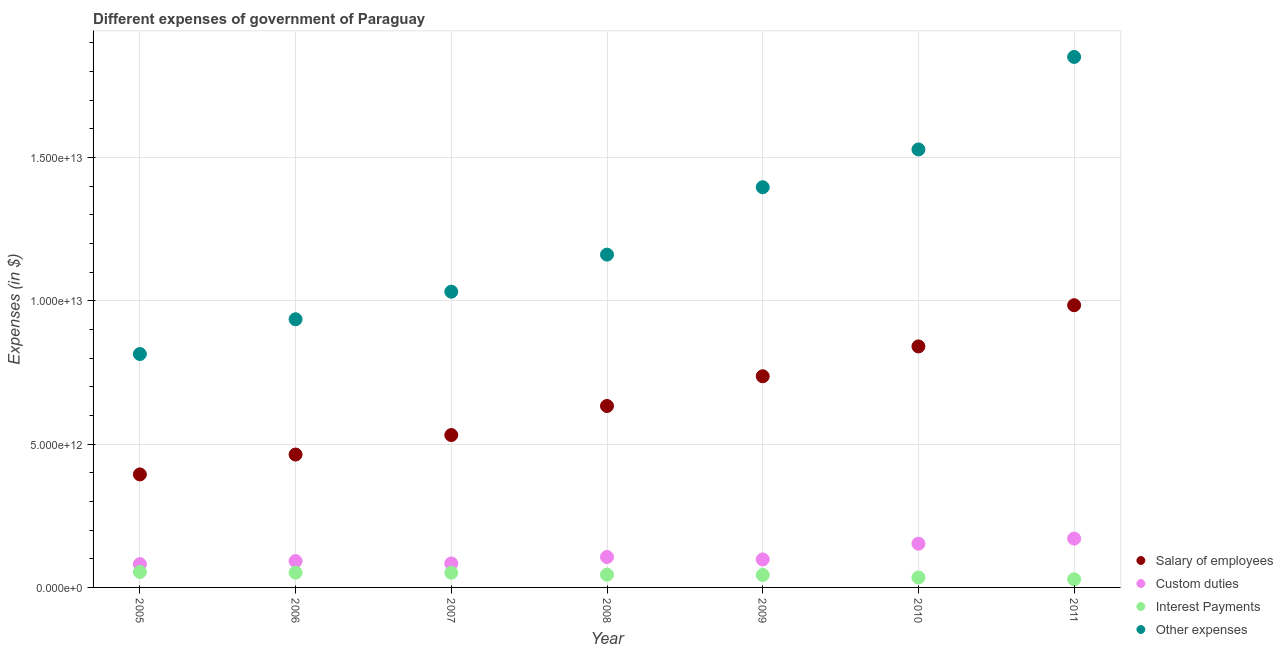How many different coloured dotlines are there?
Provide a succinct answer. 4. Is the number of dotlines equal to the number of legend labels?
Make the answer very short. Yes. What is the amount spent on other expenses in 2009?
Your answer should be very brief. 1.40e+13. Across all years, what is the maximum amount spent on salary of employees?
Your answer should be very brief. 9.85e+12. Across all years, what is the minimum amount spent on salary of employees?
Offer a terse response. 3.94e+12. In which year was the amount spent on interest payments minimum?
Your response must be concise. 2011. What is the total amount spent on salary of employees in the graph?
Provide a succinct answer. 4.59e+13. What is the difference between the amount spent on interest payments in 2007 and that in 2009?
Make the answer very short. 7.83e+1. What is the difference between the amount spent on salary of employees in 2011 and the amount spent on other expenses in 2008?
Your answer should be compact. -1.77e+12. What is the average amount spent on custom duties per year?
Keep it short and to the point. 1.12e+12. In the year 2008, what is the difference between the amount spent on salary of employees and amount spent on other expenses?
Offer a terse response. -5.28e+12. In how many years, is the amount spent on interest payments greater than 1000000000000 $?
Keep it short and to the point. 0. What is the ratio of the amount spent on interest payments in 2008 to that in 2011?
Make the answer very short. 1.57. Is the difference between the amount spent on other expenses in 2005 and 2006 greater than the difference between the amount spent on interest payments in 2005 and 2006?
Provide a short and direct response. No. What is the difference between the highest and the second highest amount spent on other expenses?
Offer a terse response. 3.23e+12. What is the difference between the highest and the lowest amount spent on salary of employees?
Your answer should be compact. 5.90e+12. In how many years, is the amount spent on salary of employees greater than the average amount spent on salary of employees taken over all years?
Your answer should be very brief. 3. Is the sum of the amount spent on salary of employees in 2010 and 2011 greater than the maximum amount spent on interest payments across all years?
Make the answer very short. Yes. How many years are there in the graph?
Offer a terse response. 7. What is the difference between two consecutive major ticks on the Y-axis?
Your response must be concise. 5.00e+12. Are the values on the major ticks of Y-axis written in scientific E-notation?
Provide a short and direct response. Yes. Does the graph contain grids?
Keep it short and to the point. Yes. How many legend labels are there?
Provide a short and direct response. 4. What is the title of the graph?
Ensure brevity in your answer.  Different expenses of government of Paraguay. Does "International Monetary Fund" appear as one of the legend labels in the graph?
Give a very brief answer. No. What is the label or title of the X-axis?
Your answer should be very brief. Year. What is the label or title of the Y-axis?
Make the answer very short. Expenses (in $). What is the Expenses (in $) in Salary of employees in 2005?
Your answer should be very brief. 3.94e+12. What is the Expenses (in $) in Custom duties in 2005?
Provide a succinct answer. 8.13e+11. What is the Expenses (in $) of Interest Payments in 2005?
Offer a very short reply. 5.40e+11. What is the Expenses (in $) in Other expenses in 2005?
Give a very brief answer. 8.15e+12. What is the Expenses (in $) of Salary of employees in 2006?
Your answer should be very brief. 4.64e+12. What is the Expenses (in $) of Custom duties in 2006?
Offer a terse response. 9.18e+11. What is the Expenses (in $) in Interest Payments in 2006?
Provide a succinct answer. 5.17e+11. What is the Expenses (in $) in Other expenses in 2006?
Ensure brevity in your answer.  9.36e+12. What is the Expenses (in $) of Salary of employees in 2007?
Provide a succinct answer. 5.32e+12. What is the Expenses (in $) in Custom duties in 2007?
Keep it short and to the point. 8.38e+11. What is the Expenses (in $) in Interest Payments in 2007?
Provide a short and direct response. 5.13e+11. What is the Expenses (in $) of Other expenses in 2007?
Provide a succinct answer. 1.03e+13. What is the Expenses (in $) in Salary of employees in 2008?
Keep it short and to the point. 6.33e+12. What is the Expenses (in $) of Custom duties in 2008?
Offer a very short reply. 1.06e+12. What is the Expenses (in $) of Interest Payments in 2008?
Ensure brevity in your answer.  4.45e+11. What is the Expenses (in $) in Other expenses in 2008?
Keep it short and to the point. 1.16e+13. What is the Expenses (in $) of Salary of employees in 2009?
Your answer should be very brief. 7.37e+12. What is the Expenses (in $) of Custom duties in 2009?
Your answer should be compact. 9.77e+11. What is the Expenses (in $) of Interest Payments in 2009?
Your response must be concise. 4.35e+11. What is the Expenses (in $) in Other expenses in 2009?
Offer a terse response. 1.40e+13. What is the Expenses (in $) in Salary of employees in 2010?
Your answer should be compact. 8.41e+12. What is the Expenses (in $) of Custom duties in 2010?
Offer a terse response. 1.53e+12. What is the Expenses (in $) in Interest Payments in 2010?
Your response must be concise. 3.46e+11. What is the Expenses (in $) in Other expenses in 2010?
Offer a very short reply. 1.53e+13. What is the Expenses (in $) of Salary of employees in 2011?
Ensure brevity in your answer.  9.85e+12. What is the Expenses (in $) of Custom duties in 2011?
Ensure brevity in your answer.  1.70e+12. What is the Expenses (in $) in Interest Payments in 2011?
Your answer should be very brief. 2.84e+11. What is the Expenses (in $) in Other expenses in 2011?
Ensure brevity in your answer.  1.85e+13. Across all years, what is the maximum Expenses (in $) of Salary of employees?
Offer a terse response. 9.85e+12. Across all years, what is the maximum Expenses (in $) of Custom duties?
Provide a succinct answer. 1.70e+12. Across all years, what is the maximum Expenses (in $) in Interest Payments?
Offer a terse response. 5.40e+11. Across all years, what is the maximum Expenses (in $) of Other expenses?
Your response must be concise. 1.85e+13. Across all years, what is the minimum Expenses (in $) of Salary of employees?
Offer a very short reply. 3.94e+12. Across all years, what is the minimum Expenses (in $) in Custom duties?
Keep it short and to the point. 8.13e+11. Across all years, what is the minimum Expenses (in $) in Interest Payments?
Provide a short and direct response. 2.84e+11. Across all years, what is the minimum Expenses (in $) of Other expenses?
Make the answer very short. 8.15e+12. What is the total Expenses (in $) in Salary of employees in the graph?
Your response must be concise. 4.59e+13. What is the total Expenses (in $) in Custom duties in the graph?
Provide a short and direct response. 7.84e+12. What is the total Expenses (in $) in Interest Payments in the graph?
Provide a short and direct response. 3.08e+12. What is the total Expenses (in $) in Other expenses in the graph?
Your response must be concise. 8.72e+13. What is the difference between the Expenses (in $) of Salary of employees in 2005 and that in 2006?
Give a very brief answer. -6.94e+11. What is the difference between the Expenses (in $) in Custom duties in 2005 and that in 2006?
Your answer should be compact. -1.06e+11. What is the difference between the Expenses (in $) of Interest Payments in 2005 and that in 2006?
Give a very brief answer. 2.30e+1. What is the difference between the Expenses (in $) in Other expenses in 2005 and that in 2006?
Ensure brevity in your answer.  -1.21e+12. What is the difference between the Expenses (in $) in Salary of employees in 2005 and that in 2007?
Offer a terse response. -1.37e+12. What is the difference between the Expenses (in $) in Custom duties in 2005 and that in 2007?
Offer a very short reply. -2.49e+1. What is the difference between the Expenses (in $) in Interest Payments in 2005 and that in 2007?
Offer a very short reply. 2.69e+1. What is the difference between the Expenses (in $) of Other expenses in 2005 and that in 2007?
Your answer should be very brief. -2.17e+12. What is the difference between the Expenses (in $) in Salary of employees in 2005 and that in 2008?
Offer a terse response. -2.39e+12. What is the difference between the Expenses (in $) of Custom duties in 2005 and that in 2008?
Your response must be concise. -2.49e+11. What is the difference between the Expenses (in $) in Interest Payments in 2005 and that in 2008?
Provide a short and direct response. 9.46e+1. What is the difference between the Expenses (in $) in Other expenses in 2005 and that in 2008?
Your answer should be compact. -3.47e+12. What is the difference between the Expenses (in $) of Salary of employees in 2005 and that in 2009?
Make the answer very short. -3.42e+12. What is the difference between the Expenses (in $) in Custom duties in 2005 and that in 2009?
Ensure brevity in your answer.  -1.65e+11. What is the difference between the Expenses (in $) in Interest Payments in 2005 and that in 2009?
Your response must be concise. 1.05e+11. What is the difference between the Expenses (in $) of Other expenses in 2005 and that in 2009?
Keep it short and to the point. -5.82e+12. What is the difference between the Expenses (in $) of Salary of employees in 2005 and that in 2010?
Your answer should be compact. -4.47e+12. What is the difference between the Expenses (in $) of Custom duties in 2005 and that in 2010?
Give a very brief answer. -7.13e+11. What is the difference between the Expenses (in $) of Interest Payments in 2005 and that in 2010?
Offer a terse response. 1.93e+11. What is the difference between the Expenses (in $) in Other expenses in 2005 and that in 2010?
Provide a succinct answer. -7.14e+12. What is the difference between the Expenses (in $) of Salary of employees in 2005 and that in 2011?
Make the answer very short. -5.90e+12. What is the difference between the Expenses (in $) of Custom duties in 2005 and that in 2011?
Your response must be concise. -8.91e+11. What is the difference between the Expenses (in $) of Interest Payments in 2005 and that in 2011?
Your response must be concise. 2.56e+11. What is the difference between the Expenses (in $) of Other expenses in 2005 and that in 2011?
Ensure brevity in your answer.  -1.04e+13. What is the difference between the Expenses (in $) in Salary of employees in 2006 and that in 2007?
Offer a very short reply. -6.80e+11. What is the difference between the Expenses (in $) in Custom duties in 2006 and that in 2007?
Offer a terse response. 8.09e+1. What is the difference between the Expenses (in $) in Interest Payments in 2006 and that in 2007?
Offer a terse response. 3.87e+09. What is the difference between the Expenses (in $) of Other expenses in 2006 and that in 2007?
Provide a short and direct response. -9.61e+11. What is the difference between the Expenses (in $) of Salary of employees in 2006 and that in 2008?
Make the answer very short. -1.69e+12. What is the difference between the Expenses (in $) in Custom duties in 2006 and that in 2008?
Offer a very short reply. -1.43e+11. What is the difference between the Expenses (in $) of Interest Payments in 2006 and that in 2008?
Your answer should be compact. 7.16e+1. What is the difference between the Expenses (in $) in Other expenses in 2006 and that in 2008?
Make the answer very short. -2.26e+12. What is the difference between the Expenses (in $) in Salary of employees in 2006 and that in 2009?
Your answer should be very brief. -2.73e+12. What is the difference between the Expenses (in $) of Custom duties in 2006 and that in 2009?
Give a very brief answer. -5.89e+1. What is the difference between the Expenses (in $) in Interest Payments in 2006 and that in 2009?
Provide a succinct answer. 8.22e+1. What is the difference between the Expenses (in $) in Other expenses in 2006 and that in 2009?
Offer a very short reply. -4.61e+12. What is the difference between the Expenses (in $) of Salary of employees in 2006 and that in 2010?
Keep it short and to the point. -3.77e+12. What is the difference between the Expenses (in $) of Custom duties in 2006 and that in 2010?
Offer a terse response. -6.07e+11. What is the difference between the Expenses (in $) of Interest Payments in 2006 and that in 2010?
Your answer should be very brief. 1.70e+11. What is the difference between the Expenses (in $) in Other expenses in 2006 and that in 2010?
Give a very brief answer. -5.93e+12. What is the difference between the Expenses (in $) in Salary of employees in 2006 and that in 2011?
Keep it short and to the point. -5.21e+12. What is the difference between the Expenses (in $) of Custom duties in 2006 and that in 2011?
Provide a short and direct response. -7.85e+11. What is the difference between the Expenses (in $) of Interest Payments in 2006 and that in 2011?
Keep it short and to the point. 2.33e+11. What is the difference between the Expenses (in $) of Other expenses in 2006 and that in 2011?
Provide a short and direct response. -9.15e+12. What is the difference between the Expenses (in $) in Salary of employees in 2007 and that in 2008?
Give a very brief answer. -1.01e+12. What is the difference between the Expenses (in $) of Custom duties in 2007 and that in 2008?
Give a very brief answer. -2.24e+11. What is the difference between the Expenses (in $) of Interest Payments in 2007 and that in 2008?
Make the answer very short. 6.77e+1. What is the difference between the Expenses (in $) in Other expenses in 2007 and that in 2008?
Keep it short and to the point. -1.29e+12. What is the difference between the Expenses (in $) of Salary of employees in 2007 and that in 2009?
Ensure brevity in your answer.  -2.05e+12. What is the difference between the Expenses (in $) in Custom duties in 2007 and that in 2009?
Offer a very short reply. -1.40e+11. What is the difference between the Expenses (in $) of Interest Payments in 2007 and that in 2009?
Keep it short and to the point. 7.83e+1. What is the difference between the Expenses (in $) of Other expenses in 2007 and that in 2009?
Your answer should be very brief. -3.65e+12. What is the difference between the Expenses (in $) of Salary of employees in 2007 and that in 2010?
Provide a succinct answer. -3.09e+12. What is the difference between the Expenses (in $) in Custom duties in 2007 and that in 2010?
Your response must be concise. -6.88e+11. What is the difference between the Expenses (in $) of Interest Payments in 2007 and that in 2010?
Provide a succinct answer. 1.66e+11. What is the difference between the Expenses (in $) in Other expenses in 2007 and that in 2010?
Make the answer very short. -4.96e+12. What is the difference between the Expenses (in $) of Salary of employees in 2007 and that in 2011?
Ensure brevity in your answer.  -4.53e+12. What is the difference between the Expenses (in $) in Custom duties in 2007 and that in 2011?
Give a very brief answer. -8.66e+11. What is the difference between the Expenses (in $) in Interest Payments in 2007 and that in 2011?
Provide a succinct answer. 2.29e+11. What is the difference between the Expenses (in $) of Other expenses in 2007 and that in 2011?
Make the answer very short. -8.19e+12. What is the difference between the Expenses (in $) of Salary of employees in 2008 and that in 2009?
Ensure brevity in your answer.  -1.04e+12. What is the difference between the Expenses (in $) in Custom duties in 2008 and that in 2009?
Offer a terse response. 8.42e+1. What is the difference between the Expenses (in $) of Interest Payments in 2008 and that in 2009?
Ensure brevity in your answer.  1.06e+1. What is the difference between the Expenses (in $) in Other expenses in 2008 and that in 2009?
Offer a very short reply. -2.35e+12. What is the difference between the Expenses (in $) of Salary of employees in 2008 and that in 2010?
Offer a terse response. -2.08e+12. What is the difference between the Expenses (in $) of Custom duties in 2008 and that in 2010?
Provide a succinct answer. -4.64e+11. What is the difference between the Expenses (in $) of Interest Payments in 2008 and that in 2010?
Your response must be concise. 9.87e+1. What is the difference between the Expenses (in $) in Other expenses in 2008 and that in 2010?
Provide a succinct answer. -3.67e+12. What is the difference between the Expenses (in $) of Salary of employees in 2008 and that in 2011?
Offer a terse response. -3.52e+12. What is the difference between the Expenses (in $) in Custom duties in 2008 and that in 2011?
Ensure brevity in your answer.  -6.42e+11. What is the difference between the Expenses (in $) in Interest Payments in 2008 and that in 2011?
Provide a short and direct response. 1.61e+11. What is the difference between the Expenses (in $) in Other expenses in 2008 and that in 2011?
Make the answer very short. -6.90e+12. What is the difference between the Expenses (in $) in Salary of employees in 2009 and that in 2010?
Your answer should be very brief. -1.04e+12. What is the difference between the Expenses (in $) of Custom duties in 2009 and that in 2010?
Keep it short and to the point. -5.48e+11. What is the difference between the Expenses (in $) of Interest Payments in 2009 and that in 2010?
Provide a succinct answer. 8.81e+1. What is the difference between the Expenses (in $) in Other expenses in 2009 and that in 2010?
Offer a terse response. -1.32e+12. What is the difference between the Expenses (in $) of Salary of employees in 2009 and that in 2011?
Offer a terse response. -2.48e+12. What is the difference between the Expenses (in $) in Custom duties in 2009 and that in 2011?
Make the answer very short. -7.27e+11. What is the difference between the Expenses (in $) in Interest Payments in 2009 and that in 2011?
Keep it short and to the point. 1.50e+11. What is the difference between the Expenses (in $) of Other expenses in 2009 and that in 2011?
Ensure brevity in your answer.  -4.55e+12. What is the difference between the Expenses (in $) in Salary of employees in 2010 and that in 2011?
Offer a very short reply. -1.44e+12. What is the difference between the Expenses (in $) in Custom duties in 2010 and that in 2011?
Your answer should be compact. -1.78e+11. What is the difference between the Expenses (in $) of Interest Payments in 2010 and that in 2011?
Offer a terse response. 6.23e+1. What is the difference between the Expenses (in $) of Other expenses in 2010 and that in 2011?
Offer a very short reply. -3.23e+12. What is the difference between the Expenses (in $) of Salary of employees in 2005 and the Expenses (in $) of Custom duties in 2006?
Offer a terse response. 3.03e+12. What is the difference between the Expenses (in $) of Salary of employees in 2005 and the Expenses (in $) of Interest Payments in 2006?
Your answer should be compact. 3.43e+12. What is the difference between the Expenses (in $) in Salary of employees in 2005 and the Expenses (in $) in Other expenses in 2006?
Provide a short and direct response. -5.41e+12. What is the difference between the Expenses (in $) of Custom duties in 2005 and the Expenses (in $) of Interest Payments in 2006?
Provide a succinct answer. 2.96e+11. What is the difference between the Expenses (in $) of Custom duties in 2005 and the Expenses (in $) of Other expenses in 2006?
Ensure brevity in your answer.  -8.55e+12. What is the difference between the Expenses (in $) in Interest Payments in 2005 and the Expenses (in $) in Other expenses in 2006?
Your response must be concise. -8.82e+12. What is the difference between the Expenses (in $) in Salary of employees in 2005 and the Expenses (in $) in Custom duties in 2007?
Keep it short and to the point. 3.11e+12. What is the difference between the Expenses (in $) of Salary of employees in 2005 and the Expenses (in $) of Interest Payments in 2007?
Your answer should be compact. 3.43e+12. What is the difference between the Expenses (in $) of Salary of employees in 2005 and the Expenses (in $) of Other expenses in 2007?
Your answer should be very brief. -6.38e+12. What is the difference between the Expenses (in $) of Custom duties in 2005 and the Expenses (in $) of Interest Payments in 2007?
Offer a terse response. 3.00e+11. What is the difference between the Expenses (in $) in Custom duties in 2005 and the Expenses (in $) in Other expenses in 2007?
Offer a very short reply. -9.51e+12. What is the difference between the Expenses (in $) of Interest Payments in 2005 and the Expenses (in $) of Other expenses in 2007?
Offer a very short reply. -9.78e+12. What is the difference between the Expenses (in $) in Salary of employees in 2005 and the Expenses (in $) in Custom duties in 2008?
Give a very brief answer. 2.88e+12. What is the difference between the Expenses (in $) of Salary of employees in 2005 and the Expenses (in $) of Interest Payments in 2008?
Offer a very short reply. 3.50e+12. What is the difference between the Expenses (in $) in Salary of employees in 2005 and the Expenses (in $) in Other expenses in 2008?
Provide a succinct answer. -7.67e+12. What is the difference between the Expenses (in $) in Custom duties in 2005 and the Expenses (in $) in Interest Payments in 2008?
Provide a succinct answer. 3.68e+11. What is the difference between the Expenses (in $) in Custom duties in 2005 and the Expenses (in $) in Other expenses in 2008?
Make the answer very short. -1.08e+13. What is the difference between the Expenses (in $) in Interest Payments in 2005 and the Expenses (in $) in Other expenses in 2008?
Offer a very short reply. -1.11e+13. What is the difference between the Expenses (in $) in Salary of employees in 2005 and the Expenses (in $) in Custom duties in 2009?
Keep it short and to the point. 2.97e+12. What is the difference between the Expenses (in $) of Salary of employees in 2005 and the Expenses (in $) of Interest Payments in 2009?
Provide a succinct answer. 3.51e+12. What is the difference between the Expenses (in $) in Salary of employees in 2005 and the Expenses (in $) in Other expenses in 2009?
Give a very brief answer. -1.00e+13. What is the difference between the Expenses (in $) of Custom duties in 2005 and the Expenses (in $) of Interest Payments in 2009?
Your answer should be very brief. 3.78e+11. What is the difference between the Expenses (in $) of Custom duties in 2005 and the Expenses (in $) of Other expenses in 2009?
Provide a succinct answer. -1.32e+13. What is the difference between the Expenses (in $) in Interest Payments in 2005 and the Expenses (in $) in Other expenses in 2009?
Ensure brevity in your answer.  -1.34e+13. What is the difference between the Expenses (in $) of Salary of employees in 2005 and the Expenses (in $) of Custom duties in 2010?
Ensure brevity in your answer.  2.42e+12. What is the difference between the Expenses (in $) in Salary of employees in 2005 and the Expenses (in $) in Interest Payments in 2010?
Make the answer very short. 3.60e+12. What is the difference between the Expenses (in $) in Salary of employees in 2005 and the Expenses (in $) in Other expenses in 2010?
Offer a terse response. -1.13e+13. What is the difference between the Expenses (in $) of Custom duties in 2005 and the Expenses (in $) of Interest Payments in 2010?
Provide a succinct answer. 4.66e+11. What is the difference between the Expenses (in $) in Custom duties in 2005 and the Expenses (in $) in Other expenses in 2010?
Provide a succinct answer. -1.45e+13. What is the difference between the Expenses (in $) in Interest Payments in 2005 and the Expenses (in $) in Other expenses in 2010?
Give a very brief answer. -1.47e+13. What is the difference between the Expenses (in $) in Salary of employees in 2005 and the Expenses (in $) in Custom duties in 2011?
Your answer should be very brief. 2.24e+12. What is the difference between the Expenses (in $) of Salary of employees in 2005 and the Expenses (in $) of Interest Payments in 2011?
Provide a succinct answer. 3.66e+12. What is the difference between the Expenses (in $) of Salary of employees in 2005 and the Expenses (in $) of Other expenses in 2011?
Your answer should be very brief. -1.46e+13. What is the difference between the Expenses (in $) of Custom duties in 2005 and the Expenses (in $) of Interest Payments in 2011?
Provide a short and direct response. 5.29e+11. What is the difference between the Expenses (in $) in Custom duties in 2005 and the Expenses (in $) in Other expenses in 2011?
Offer a terse response. -1.77e+13. What is the difference between the Expenses (in $) of Interest Payments in 2005 and the Expenses (in $) of Other expenses in 2011?
Ensure brevity in your answer.  -1.80e+13. What is the difference between the Expenses (in $) in Salary of employees in 2006 and the Expenses (in $) in Custom duties in 2007?
Give a very brief answer. 3.80e+12. What is the difference between the Expenses (in $) in Salary of employees in 2006 and the Expenses (in $) in Interest Payments in 2007?
Your answer should be very brief. 4.12e+12. What is the difference between the Expenses (in $) in Salary of employees in 2006 and the Expenses (in $) in Other expenses in 2007?
Offer a very short reply. -5.68e+12. What is the difference between the Expenses (in $) in Custom duties in 2006 and the Expenses (in $) in Interest Payments in 2007?
Keep it short and to the point. 4.06e+11. What is the difference between the Expenses (in $) of Custom duties in 2006 and the Expenses (in $) of Other expenses in 2007?
Offer a very short reply. -9.40e+12. What is the difference between the Expenses (in $) of Interest Payments in 2006 and the Expenses (in $) of Other expenses in 2007?
Your answer should be very brief. -9.80e+12. What is the difference between the Expenses (in $) in Salary of employees in 2006 and the Expenses (in $) in Custom duties in 2008?
Provide a short and direct response. 3.58e+12. What is the difference between the Expenses (in $) in Salary of employees in 2006 and the Expenses (in $) in Interest Payments in 2008?
Make the answer very short. 4.19e+12. What is the difference between the Expenses (in $) of Salary of employees in 2006 and the Expenses (in $) of Other expenses in 2008?
Provide a short and direct response. -6.98e+12. What is the difference between the Expenses (in $) in Custom duties in 2006 and the Expenses (in $) in Interest Payments in 2008?
Offer a terse response. 4.73e+11. What is the difference between the Expenses (in $) in Custom duties in 2006 and the Expenses (in $) in Other expenses in 2008?
Make the answer very short. -1.07e+13. What is the difference between the Expenses (in $) in Interest Payments in 2006 and the Expenses (in $) in Other expenses in 2008?
Offer a terse response. -1.11e+13. What is the difference between the Expenses (in $) in Salary of employees in 2006 and the Expenses (in $) in Custom duties in 2009?
Provide a succinct answer. 3.66e+12. What is the difference between the Expenses (in $) in Salary of employees in 2006 and the Expenses (in $) in Interest Payments in 2009?
Give a very brief answer. 4.20e+12. What is the difference between the Expenses (in $) in Salary of employees in 2006 and the Expenses (in $) in Other expenses in 2009?
Offer a terse response. -9.33e+12. What is the difference between the Expenses (in $) in Custom duties in 2006 and the Expenses (in $) in Interest Payments in 2009?
Provide a succinct answer. 4.84e+11. What is the difference between the Expenses (in $) in Custom duties in 2006 and the Expenses (in $) in Other expenses in 2009?
Your answer should be compact. -1.30e+13. What is the difference between the Expenses (in $) of Interest Payments in 2006 and the Expenses (in $) of Other expenses in 2009?
Provide a succinct answer. -1.34e+13. What is the difference between the Expenses (in $) in Salary of employees in 2006 and the Expenses (in $) in Custom duties in 2010?
Your answer should be compact. 3.11e+12. What is the difference between the Expenses (in $) of Salary of employees in 2006 and the Expenses (in $) of Interest Payments in 2010?
Ensure brevity in your answer.  4.29e+12. What is the difference between the Expenses (in $) of Salary of employees in 2006 and the Expenses (in $) of Other expenses in 2010?
Your answer should be very brief. -1.06e+13. What is the difference between the Expenses (in $) in Custom duties in 2006 and the Expenses (in $) in Interest Payments in 2010?
Your answer should be compact. 5.72e+11. What is the difference between the Expenses (in $) in Custom duties in 2006 and the Expenses (in $) in Other expenses in 2010?
Give a very brief answer. -1.44e+13. What is the difference between the Expenses (in $) of Interest Payments in 2006 and the Expenses (in $) of Other expenses in 2010?
Your response must be concise. -1.48e+13. What is the difference between the Expenses (in $) in Salary of employees in 2006 and the Expenses (in $) in Custom duties in 2011?
Offer a very short reply. 2.93e+12. What is the difference between the Expenses (in $) of Salary of employees in 2006 and the Expenses (in $) of Interest Payments in 2011?
Keep it short and to the point. 4.35e+12. What is the difference between the Expenses (in $) in Salary of employees in 2006 and the Expenses (in $) in Other expenses in 2011?
Offer a very short reply. -1.39e+13. What is the difference between the Expenses (in $) of Custom duties in 2006 and the Expenses (in $) of Interest Payments in 2011?
Your answer should be compact. 6.34e+11. What is the difference between the Expenses (in $) in Custom duties in 2006 and the Expenses (in $) in Other expenses in 2011?
Keep it short and to the point. -1.76e+13. What is the difference between the Expenses (in $) in Interest Payments in 2006 and the Expenses (in $) in Other expenses in 2011?
Provide a succinct answer. -1.80e+13. What is the difference between the Expenses (in $) in Salary of employees in 2007 and the Expenses (in $) in Custom duties in 2008?
Your response must be concise. 4.26e+12. What is the difference between the Expenses (in $) of Salary of employees in 2007 and the Expenses (in $) of Interest Payments in 2008?
Offer a very short reply. 4.87e+12. What is the difference between the Expenses (in $) in Salary of employees in 2007 and the Expenses (in $) in Other expenses in 2008?
Offer a terse response. -6.30e+12. What is the difference between the Expenses (in $) in Custom duties in 2007 and the Expenses (in $) in Interest Payments in 2008?
Offer a terse response. 3.92e+11. What is the difference between the Expenses (in $) of Custom duties in 2007 and the Expenses (in $) of Other expenses in 2008?
Make the answer very short. -1.08e+13. What is the difference between the Expenses (in $) of Interest Payments in 2007 and the Expenses (in $) of Other expenses in 2008?
Ensure brevity in your answer.  -1.11e+13. What is the difference between the Expenses (in $) of Salary of employees in 2007 and the Expenses (in $) of Custom duties in 2009?
Give a very brief answer. 4.34e+12. What is the difference between the Expenses (in $) of Salary of employees in 2007 and the Expenses (in $) of Interest Payments in 2009?
Give a very brief answer. 4.88e+12. What is the difference between the Expenses (in $) of Salary of employees in 2007 and the Expenses (in $) of Other expenses in 2009?
Your answer should be compact. -8.65e+12. What is the difference between the Expenses (in $) in Custom duties in 2007 and the Expenses (in $) in Interest Payments in 2009?
Provide a succinct answer. 4.03e+11. What is the difference between the Expenses (in $) in Custom duties in 2007 and the Expenses (in $) in Other expenses in 2009?
Your answer should be compact. -1.31e+13. What is the difference between the Expenses (in $) in Interest Payments in 2007 and the Expenses (in $) in Other expenses in 2009?
Provide a short and direct response. -1.35e+13. What is the difference between the Expenses (in $) of Salary of employees in 2007 and the Expenses (in $) of Custom duties in 2010?
Ensure brevity in your answer.  3.79e+12. What is the difference between the Expenses (in $) of Salary of employees in 2007 and the Expenses (in $) of Interest Payments in 2010?
Offer a terse response. 4.97e+12. What is the difference between the Expenses (in $) of Salary of employees in 2007 and the Expenses (in $) of Other expenses in 2010?
Your answer should be compact. -9.97e+12. What is the difference between the Expenses (in $) of Custom duties in 2007 and the Expenses (in $) of Interest Payments in 2010?
Offer a very short reply. 4.91e+11. What is the difference between the Expenses (in $) of Custom duties in 2007 and the Expenses (in $) of Other expenses in 2010?
Provide a short and direct response. -1.44e+13. What is the difference between the Expenses (in $) in Interest Payments in 2007 and the Expenses (in $) in Other expenses in 2010?
Offer a very short reply. -1.48e+13. What is the difference between the Expenses (in $) of Salary of employees in 2007 and the Expenses (in $) of Custom duties in 2011?
Your answer should be compact. 3.61e+12. What is the difference between the Expenses (in $) in Salary of employees in 2007 and the Expenses (in $) in Interest Payments in 2011?
Your answer should be compact. 5.03e+12. What is the difference between the Expenses (in $) in Salary of employees in 2007 and the Expenses (in $) in Other expenses in 2011?
Offer a terse response. -1.32e+13. What is the difference between the Expenses (in $) of Custom duties in 2007 and the Expenses (in $) of Interest Payments in 2011?
Offer a very short reply. 5.53e+11. What is the difference between the Expenses (in $) of Custom duties in 2007 and the Expenses (in $) of Other expenses in 2011?
Give a very brief answer. -1.77e+13. What is the difference between the Expenses (in $) of Interest Payments in 2007 and the Expenses (in $) of Other expenses in 2011?
Provide a short and direct response. -1.80e+13. What is the difference between the Expenses (in $) in Salary of employees in 2008 and the Expenses (in $) in Custom duties in 2009?
Provide a succinct answer. 5.35e+12. What is the difference between the Expenses (in $) of Salary of employees in 2008 and the Expenses (in $) of Interest Payments in 2009?
Offer a terse response. 5.90e+12. What is the difference between the Expenses (in $) of Salary of employees in 2008 and the Expenses (in $) of Other expenses in 2009?
Keep it short and to the point. -7.63e+12. What is the difference between the Expenses (in $) in Custom duties in 2008 and the Expenses (in $) in Interest Payments in 2009?
Make the answer very short. 6.27e+11. What is the difference between the Expenses (in $) in Custom duties in 2008 and the Expenses (in $) in Other expenses in 2009?
Provide a succinct answer. -1.29e+13. What is the difference between the Expenses (in $) in Interest Payments in 2008 and the Expenses (in $) in Other expenses in 2009?
Give a very brief answer. -1.35e+13. What is the difference between the Expenses (in $) in Salary of employees in 2008 and the Expenses (in $) in Custom duties in 2010?
Provide a succinct answer. 4.81e+12. What is the difference between the Expenses (in $) in Salary of employees in 2008 and the Expenses (in $) in Interest Payments in 2010?
Offer a very short reply. 5.98e+12. What is the difference between the Expenses (in $) of Salary of employees in 2008 and the Expenses (in $) of Other expenses in 2010?
Offer a very short reply. -8.95e+12. What is the difference between the Expenses (in $) in Custom duties in 2008 and the Expenses (in $) in Interest Payments in 2010?
Offer a very short reply. 7.15e+11. What is the difference between the Expenses (in $) of Custom duties in 2008 and the Expenses (in $) of Other expenses in 2010?
Your response must be concise. -1.42e+13. What is the difference between the Expenses (in $) in Interest Payments in 2008 and the Expenses (in $) in Other expenses in 2010?
Provide a short and direct response. -1.48e+13. What is the difference between the Expenses (in $) in Salary of employees in 2008 and the Expenses (in $) in Custom duties in 2011?
Provide a short and direct response. 4.63e+12. What is the difference between the Expenses (in $) of Salary of employees in 2008 and the Expenses (in $) of Interest Payments in 2011?
Offer a terse response. 6.05e+12. What is the difference between the Expenses (in $) of Salary of employees in 2008 and the Expenses (in $) of Other expenses in 2011?
Provide a short and direct response. -1.22e+13. What is the difference between the Expenses (in $) in Custom duties in 2008 and the Expenses (in $) in Interest Payments in 2011?
Make the answer very short. 7.77e+11. What is the difference between the Expenses (in $) in Custom duties in 2008 and the Expenses (in $) in Other expenses in 2011?
Offer a very short reply. -1.74e+13. What is the difference between the Expenses (in $) in Interest Payments in 2008 and the Expenses (in $) in Other expenses in 2011?
Your answer should be compact. -1.81e+13. What is the difference between the Expenses (in $) in Salary of employees in 2009 and the Expenses (in $) in Custom duties in 2010?
Provide a short and direct response. 5.84e+12. What is the difference between the Expenses (in $) in Salary of employees in 2009 and the Expenses (in $) in Interest Payments in 2010?
Offer a very short reply. 7.02e+12. What is the difference between the Expenses (in $) in Salary of employees in 2009 and the Expenses (in $) in Other expenses in 2010?
Your response must be concise. -7.91e+12. What is the difference between the Expenses (in $) in Custom duties in 2009 and the Expenses (in $) in Interest Payments in 2010?
Ensure brevity in your answer.  6.31e+11. What is the difference between the Expenses (in $) in Custom duties in 2009 and the Expenses (in $) in Other expenses in 2010?
Offer a terse response. -1.43e+13. What is the difference between the Expenses (in $) in Interest Payments in 2009 and the Expenses (in $) in Other expenses in 2010?
Give a very brief answer. -1.48e+13. What is the difference between the Expenses (in $) of Salary of employees in 2009 and the Expenses (in $) of Custom duties in 2011?
Your answer should be very brief. 5.66e+12. What is the difference between the Expenses (in $) in Salary of employees in 2009 and the Expenses (in $) in Interest Payments in 2011?
Your answer should be compact. 7.08e+12. What is the difference between the Expenses (in $) of Salary of employees in 2009 and the Expenses (in $) of Other expenses in 2011?
Your answer should be compact. -1.11e+13. What is the difference between the Expenses (in $) in Custom duties in 2009 and the Expenses (in $) in Interest Payments in 2011?
Provide a succinct answer. 6.93e+11. What is the difference between the Expenses (in $) in Custom duties in 2009 and the Expenses (in $) in Other expenses in 2011?
Offer a terse response. -1.75e+13. What is the difference between the Expenses (in $) of Interest Payments in 2009 and the Expenses (in $) of Other expenses in 2011?
Your answer should be very brief. -1.81e+13. What is the difference between the Expenses (in $) of Salary of employees in 2010 and the Expenses (in $) of Custom duties in 2011?
Provide a short and direct response. 6.71e+12. What is the difference between the Expenses (in $) of Salary of employees in 2010 and the Expenses (in $) of Interest Payments in 2011?
Provide a short and direct response. 8.13e+12. What is the difference between the Expenses (in $) of Salary of employees in 2010 and the Expenses (in $) of Other expenses in 2011?
Your response must be concise. -1.01e+13. What is the difference between the Expenses (in $) of Custom duties in 2010 and the Expenses (in $) of Interest Payments in 2011?
Offer a terse response. 1.24e+12. What is the difference between the Expenses (in $) of Custom duties in 2010 and the Expenses (in $) of Other expenses in 2011?
Keep it short and to the point. -1.70e+13. What is the difference between the Expenses (in $) in Interest Payments in 2010 and the Expenses (in $) in Other expenses in 2011?
Offer a very short reply. -1.82e+13. What is the average Expenses (in $) of Salary of employees per year?
Give a very brief answer. 6.55e+12. What is the average Expenses (in $) of Custom duties per year?
Ensure brevity in your answer.  1.12e+12. What is the average Expenses (in $) in Interest Payments per year?
Your answer should be very brief. 4.40e+11. What is the average Expenses (in $) in Other expenses per year?
Keep it short and to the point. 1.25e+13. In the year 2005, what is the difference between the Expenses (in $) in Salary of employees and Expenses (in $) in Custom duties?
Keep it short and to the point. 3.13e+12. In the year 2005, what is the difference between the Expenses (in $) of Salary of employees and Expenses (in $) of Interest Payments?
Your answer should be very brief. 3.40e+12. In the year 2005, what is the difference between the Expenses (in $) of Salary of employees and Expenses (in $) of Other expenses?
Provide a succinct answer. -4.20e+12. In the year 2005, what is the difference between the Expenses (in $) in Custom duties and Expenses (in $) in Interest Payments?
Offer a terse response. 2.73e+11. In the year 2005, what is the difference between the Expenses (in $) in Custom duties and Expenses (in $) in Other expenses?
Provide a short and direct response. -7.33e+12. In the year 2005, what is the difference between the Expenses (in $) in Interest Payments and Expenses (in $) in Other expenses?
Your answer should be very brief. -7.61e+12. In the year 2006, what is the difference between the Expenses (in $) in Salary of employees and Expenses (in $) in Custom duties?
Provide a short and direct response. 3.72e+12. In the year 2006, what is the difference between the Expenses (in $) of Salary of employees and Expenses (in $) of Interest Payments?
Provide a short and direct response. 4.12e+12. In the year 2006, what is the difference between the Expenses (in $) in Salary of employees and Expenses (in $) in Other expenses?
Offer a very short reply. -4.72e+12. In the year 2006, what is the difference between the Expenses (in $) of Custom duties and Expenses (in $) of Interest Payments?
Your answer should be compact. 4.02e+11. In the year 2006, what is the difference between the Expenses (in $) in Custom duties and Expenses (in $) in Other expenses?
Ensure brevity in your answer.  -8.44e+12. In the year 2006, what is the difference between the Expenses (in $) of Interest Payments and Expenses (in $) of Other expenses?
Give a very brief answer. -8.84e+12. In the year 2007, what is the difference between the Expenses (in $) of Salary of employees and Expenses (in $) of Custom duties?
Offer a very short reply. 4.48e+12. In the year 2007, what is the difference between the Expenses (in $) in Salary of employees and Expenses (in $) in Interest Payments?
Ensure brevity in your answer.  4.80e+12. In the year 2007, what is the difference between the Expenses (in $) in Salary of employees and Expenses (in $) in Other expenses?
Your answer should be compact. -5.00e+12. In the year 2007, what is the difference between the Expenses (in $) in Custom duties and Expenses (in $) in Interest Payments?
Make the answer very short. 3.25e+11. In the year 2007, what is the difference between the Expenses (in $) in Custom duties and Expenses (in $) in Other expenses?
Your answer should be compact. -9.48e+12. In the year 2007, what is the difference between the Expenses (in $) of Interest Payments and Expenses (in $) of Other expenses?
Give a very brief answer. -9.81e+12. In the year 2008, what is the difference between the Expenses (in $) in Salary of employees and Expenses (in $) in Custom duties?
Keep it short and to the point. 5.27e+12. In the year 2008, what is the difference between the Expenses (in $) of Salary of employees and Expenses (in $) of Interest Payments?
Offer a terse response. 5.89e+12. In the year 2008, what is the difference between the Expenses (in $) in Salary of employees and Expenses (in $) in Other expenses?
Give a very brief answer. -5.28e+12. In the year 2008, what is the difference between the Expenses (in $) in Custom duties and Expenses (in $) in Interest Payments?
Give a very brief answer. 6.16e+11. In the year 2008, what is the difference between the Expenses (in $) in Custom duties and Expenses (in $) in Other expenses?
Offer a very short reply. -1.06e+13. In the year 2008, what is the difference between the Expenses (in $) of Interest Payments and Expenses (in $) of Other expenses?
Give a very brief answer. -1.12e+13. In the year 2009, what is the difference between the Expenses (in $) of Salary of employees and Expenses (in $) of Custom duties?
Your response must be concise. 6.39e+12. In the year 2009, what is the difference between the Expenses (in $) in Salary of employees and Expenses (in $) in Interest Payments?
Make the answer very short. 6.93e+12. In the year 2009, what is the difference between the Expenses (in $) in Salary of employees and Expenses (in $) in Other expenses?
Your answer should be very brief. -6.60e+12. In the year 2009, what is the difference between the Expenses (in $) of Custom duties and Expenses (in $) of Interest Payments?
Offer a terse response. 5.43e+11. In the year 2009, what is the difference between the Expenses (in $) of Custom duties and Expenses (in $) of Other expenses?
Provide a short and direct response. -1.30e+13. In the year 2009, what is the difference between the Expenses (in $) in Interest Payments and Expenses (in $) in Other expenses?
Offer a terse response. -1.35e+13. In the year 2010, what is the difference between the Expenses (in $) of Salary of employees and Expenses (in $) of Custom duties?
Make the answer very short. 6.88e+12. In the year 2010, what is the difference between the Expenses (in $) in Salary of employees and Expenses (in $) in Interest Payments?
Provide a succinct answer. 8.06e+12. In the year 2010, what is the difference between the Expenses (in $) in Salary of employees and Expenses (in $) in Other expenses?
Offer a very short reply. -6.87e+12. In the year 2010, what is the difference between the Expenses (in $) of Custom duties and Expenses (in $) of Interest Payments?
Keep it short and to the point. 1.18e+12. In the year 2010, what is the difference between the Expenses (in $) in Custom duties and Expenses (in $) in Other expenses?
Your answer should be very brief. -1.38e+13. In the year 2010, what is the difference between the Expenses (in $) of Interest Payments and Expenses (in $) of Other expenses?
Your response must be concise. -1.49e+13. In the year 2011, what is the difference between the Expenses (in $) of Salary of employees and Expenses (in $) of Custom duties?
Offer a terse response. 8.14e+12. In the year 2011, what is the difference between the Expenses (in $) of Salary of employees and Expenses (in $) of Interest Payments?
Keep it short and to the point. 9.56e+12. In the year 2011, what is the difference between the Expenses (in $) in Salary of employees and Expenses (in $) in Other expenses?
Keep it short and to the point. -8.66e+12. In the year 2011, what is the difference between the Expenses (in $) in Custom duties and Expenses (in $) in Interest Payments?
Your response must be concise. 1.42e+12. In the year 2011, what is the difference between the Expenses (in $) in Custom duties and Expenses (in $) in Other expenses?
Offer a very short reply. -1.68e+13. In the year 2011, what is the difference between the Expenses (in $) of Interest Payments and Expenses (in $) of Other expenses?
Ensure brevity in your answer.  -1.82e+13. What is the ratio of the Expenses (in $) of Salary of employees in 2005 to that in 2006?
Your answer should be very brief. 0.85. What is the ratio of the Expenses (in $) in Custom duties in 2005 to that in 2006?
Give a very brief answer. 0.88. What is the ratio of the Expenses (in $) of Interest Payments in 2005 to that in 2006?
Your answer should be compact. 1.04. What is the ratio of the Expenses (in $) in Other expenses in 2005 to that in 2006?
Make the answer very short. 0.87. What is the ratio of the Expenses (in $) in Salary of employees in 2005 to that in 2007?
Ensure brevity in your answer.  0.74. What is the ratio of the Expenses (in $) in Custom duties in 2005 to that in 2007?
Ensure brevity in your answer.  0.97. What is the ratio of the Expenses (in $) of Interest Payments in 2005 to that in 2007?
Keep it short and to the point. 1.05. What is the ratio of the Expenses (in $) in Other expenses in 2005 to that in 2007?
Give a very brief answer. 0.79. What is the ratio of the Expenses (in $) of Salary of employees in 2005 to that in 2008?
Keep it short and to the point. 0.62. What is the ratio of the Expenses (in $) of Custom duties in 2005 to that in 2008?
Give a very brief answer. 0.77. What is the ratio of the Expenses (in $) of Interest Payments in 2005 to that in 2008?
Ensure brevity in your answer.  1.21. What is the ratio of the Expenses (in $) in Other expenses in 2005 to that in 2008?
Your answer should be compact. 0.7. What is the ratio of the Expenses (in $) in Salary of employees in 2005 to that in 2009?
Offer a terse response. 0.54. What is the ratio of the Expenses (in $) in Custom duties in 2005 to that in 2009?
Your answer should be very brief. 0.83. What is the ratio of the Expenses (in $) of Interest Payments in 2005 to that in 2009?
Your answer should be very brief. 1.24. What is the ratio of the Expenses (in $) of Other expenses in 2005 to that in 2009?
Your response must be concise. 0.58. What is the ratio of the Expenses (in $) of Salary of employees in 2005 to that in 2010?
Provide a succinct answer. 0.47. What is the ratio of the Expenses (in $) in Custom duties in 2005 to that in 2010?
Offer a terse response. 0.53. What is the ratio of the Expenses (in $) in Interest Payments in 2005 to that in 2010?
Ensure brevity in your answer.  1.56. What is the ratio of the Expenses (in $) of Other expenses in 2005 to that in 2010?
Your answer should be compact. 0.53. What is the ratio of the Expenses (in $) in Salary of employees in 2005 to that in 2011?
Your response must be concise. 0.4. What is the ratio of the Expenses (in $) of Custom duties in 2005 to that in 2011?
Give a very brief answer. 0.48. What is the ratio of the Expenses (in $) in Interest Payments in 2005 to that in 2011?
Ensure brevity in your answer.  1.9. What is the ratio of the Expenses (in $) in Other expenses in 2005 to that in 2011?
Your response must be concise. 0.44. What is the ratio of the Expenses (in $) in Salary of employees in 2006 to that in 2007?
Offer a very short reply. 0.87. What is the ratio of the Expenses (in $) of Custom duties in 2006 to that in 2007?
Offer a very short reply. 1.1. What is the ratio of the Expenses (in $) of Interest Payments in 2006 to that in 2007?
Ensure brevity in your answer.  1.01. What is the ratio of the Expenses (in $) of Other expenses in 2006 to that in 2007?
Keep it short and to the point. 0.91. What is the ratio of the Expenses (in $) of Salary of employees in 2006 to that in 2008?
Offer a terse response. 0.73. What is the ratio of the Expenses (in $) in Custom duties in 2006 to that in 2008?
Provide a short and direct response. 0.87. What is the ratio of the Expenses (in $) in Interest Payments in 2006 to that in 2008?
Provide a short and direct response. 1.16. What is the ratio of the Expenses (in $) in Other expenses in 2006 to that in 2008?
Your answer should be very brief. 0.81. What is the ratio of the Expenses (in $) in Salary of employees in 2006 to that in 2009?
Your answer should be compact. 0.63. What is the ratio of the Expenses (in $) of Custom duties in 2006 to that in 2009?
Your answer should be very brief. 0.94. What is the ratio of the Expenses (in $) in Interest Payments in 2006 to that in 2009?
Make the answer very short. 1.19. What is the ratio of the Expenses (in $) of Other expenses in 2006 to that in 2009?
Offer a terse response. 0.67. What is the ratio of the Expenses (in $) of Salary of employees in 2006 to that in 2010?
Provide a short and direct response. 0.55. What is the ratio of the Expenses (in $) in Custom duties in 2006 to that in 2010?
Offer a terse response. 0.6. What is the ratio of the Expenses (in $) in Interest Payments in 2006 to that in 2010?
Make the answer very short. 1.49. What is the ratio of the Expenses (in $) in Other expenses in 2006 to that in 2010?
Make the answer very short. 0.61. What is the ratio of the Expenses (in $) in Salary of employees in 2006 to that in 2011?
Provide a succinct answer. 0.47. What is the ratio of the Expenses (in $) of Custom duties in 2006 to that in 2011?
Offer a very short reply. 0.54. What is the ratio of the Expenses (in $) of Interest Payments in 2006 to that in 2011?
Your answer should be very brief. 1.82. What is the ratio of the Expenses (in $) of Other expenses in 2006 to that in 2011?
Your response must be concise. 0.51. What is the ratio of the Expenses (in $) of Salary of employees in 2007 to that in 2008?
Your answer should be compact. 0.84. What is the ratio of the Expenses (in $) in Custom duties in 2007 to that in 2008?
Provide a succinct answer. 0.79. What is the ratio of the Expenses (in $) of Interest Payments in 2007 to that in 2008?
Keep it short and to the point. 1.15. What is the ratio of the Expenses (in $) in Other expenses in 2007 to that in 2008?
Your response must be concise. 0.89. What is the ratio of the Expenses (in $) in Salary of employees in 2007 to that in 2009?
Your response must be concise. 0.72. What is the ratio of the Expenses (in $) in Custom duties in 2007 to that in 2009?
Make the answer very short. 0.86. What is the ratio of the Expenses (in $) of Interest Payments in 2007 to that in 2009?
Ensure brevity in your answer.  1.18. What is the ratio of the Expenses (in $) of Other expenses in 2007 to that in 2009?
Your answer should be very brief. 0.74. What is the ratio of the Expenses (in $) of Salary of employees in 2007 to that in 2010?
Keep it short and to the point. 0.63. What is the ratio of the Expenses (in $) in Custom duties in 2007 to that in 2010?
Your answer should be compact. 0.55. What is the ratio of the Expenses (in $) in Interest Payments in 2007 to that in 2010?
Provide a succinct answer. 1.48. What is the ratio of the Expenses (in $) of Other expenses in 2007 to that in 2010?
Your answer should be compact. 0.68. What is the ratio of the Expenses (in $) in Salary of employees in 2007 to that in 2011?
Offer a very short reply. 0.54. What is the ratio of the Expenses (in $) in Custom duties in 2007 to that in 2011?
Ensure brevity in your answer.  0.49. What is the ratio of the Expenses (in $) of Interest Payments in 2007 to that in 2011?
Your answer should be compact. 1.8. What is the ratio of the Expenses (in $) of Other expenses in 2007 to that in 2011?
Your response must be concise. 0.56. What is the ratio of the Expenses (in $) of Salary of employees in 2008 to that in 2009?
Ensure brevity in your answer.  0.86. What is the ratio of the Expenses (in $) in Custom duties in 2008 to that in 2009?
Your answer should be compact. 1.09. What is the ratio of the Expenses (in $) in Interest Payments in 2008 to that in 2009?
Make the answer very short. 1.02. What is the ratio of the Expenses (in $) in Other expenses in 2008 to that in 2009?
Offer a very short reply. 0.83. What is the ratio of the Expenses (in $) of Salary of employees in 2008 to that in 2010?
Your response must be concise. 0.75. What is the ratio of the Expenses (in $) in Custom duties in 2008 to that in 2010?
Give a very brief answer. 0.7. What is the ratio of the Expenses (in $) of Interest Payments in 2008 to that in 2010?
Provide a short and direct response. 1.29. What is the ratio of the Expenses (in $) in Other expenses in 2008 to that in 2010?
Your response must be concise. 0.76. What is the ratio of the Expenses (in $) of Salary of employees in 2008 to that in 2011?
Offer a very short reply. 0.64. What is the ratio of the Expenses (in $) in Custom duties in 2008 to that in 2011?
Your answer should be very brief. 0.62. What is the ratio of the Expenses (in $) in Interest Payments in 2008 to that in 2011?
Your response must be concise. 1.57. What is the ratio of the Expenses (in $) in Other expenses in 2008 to that in 2011?
Offer a terse response. 0.63. What is the ratio of the Expenses (in $) in Salary of employees in 2009 to that in 2010?
Provide a succinct answer. 0.88. What is the ratio of the Expenses (in $) in Custom duties in 2009 to that in 2010?
Give a very brief answer. 0.64. What is the ratio of the Expenses (in $) in Interest Payments in 2009 to that in 2010?
Make the answer very short. 1.25. What is the ratio of the Expenses (in $) of Other expenses in 2009 to that in 2010?
Make the answer very short. 0.91. What is the ratio of the Expenses (in $) in Salary of employees in 2009 to that in 2011?
Your answer should be compact. 0.75. What is the ratio of the Expenses (in $) of Custom duties in 2009 to that in 2011?
Give a very brief answer. 0.57. What is the ratio of the Expenses (in $) in Interest Payments in 2009 to that in 2011?
Make the answer very short. 1.53. What is the ratio of the Expenses (in $) of Other expenses in 2009 to that in 2011?
Your response must be concise. 0.75. What is the ratio of the Expenses (in $) of Salary of employees in 2010 to that in 2011?
Provide a succinct answer. 0.85. What is the ratio of the Expenses (in $) in Custom duties in 2010 to that in 2011?
Provide a succinct answer. 0.9. What is the ratio of the Expenses (in $) in Interest Payments in 2010 to that in 2011?
Ensure brevity in your answer.  1.22. What is the ratio of the Expenses (in $) of Other expenses in 2010 to that in 2011?
Provide a succinct answer. 0.83. What is the difference between the highest and the second highest Expenses (in $) in Salary of employees?
Your response must be concise. 1.44e+12. What is the difference between the highest and the second highest Expenses (in $) of Custom duties?
Ensure brevity in your answer.  1.78e+11. What is the difference between the highest and the second highest Expenses (in $) of Interest Payments?
Offer a terse response. 2.30e+1. What is the difference between the highest and the second highest Expenses (in $) in Other expenses?
Provide a short and direct response. 3.23e+12. What is the difference between the highest and the lowest Expenses (in $) in Salary of employees?
Ensure brevity in your answer.  5.90e+12. What is the difference between the highest and the lowest Expenses (in $) of Custom duties?
Provide a succinct answer. 8.91e+11. What is the difference between the highest and the lowest Expenses (in $) in Interest Payments?
Your answer should be very brief. 2.56e+11. What is the difference between the highest and the lowest Expenses (in $) of Other expenses?
Keep it short and to the point. 1.04e+13. 